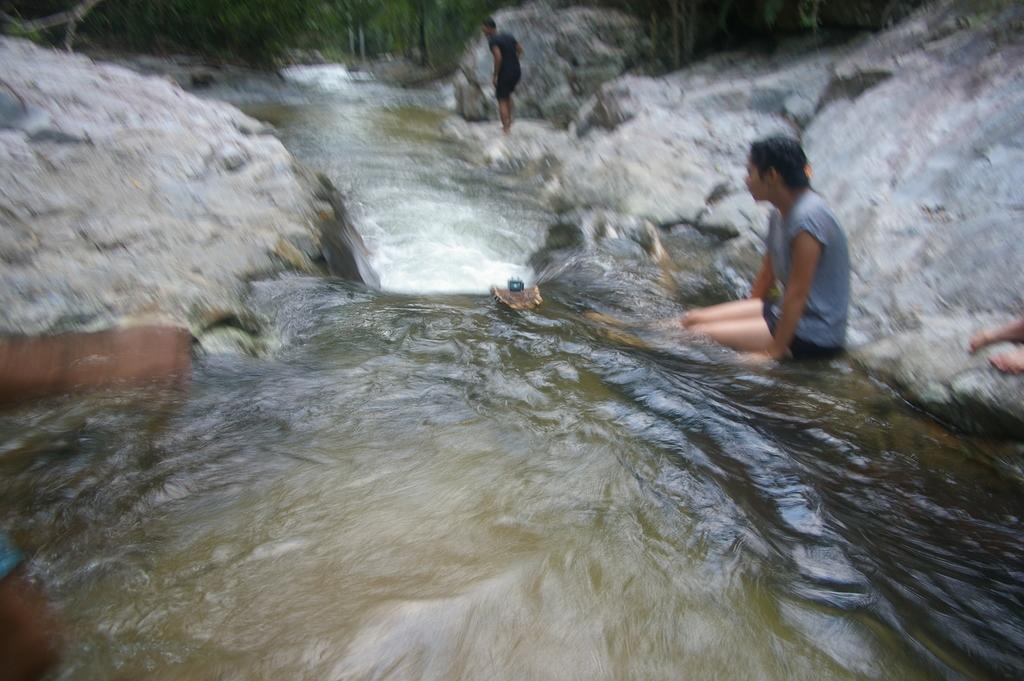Describe this image in one or two sentences. In this image we can see big rocks. There are few people in the image. There is a flow of water in the image There are many trees in the image. 